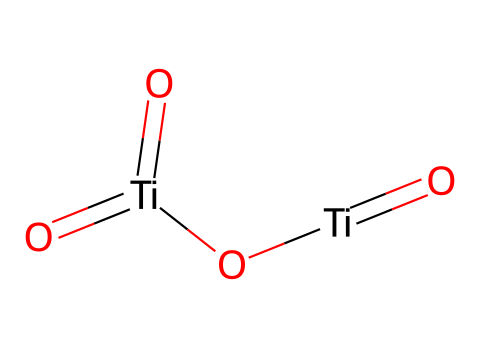What is the chemical formula for the compound represented? The SMILES representation shows two titanium (Ti) atoms, each bonded to three oxygen (O) atoms, which can be counted from the chemical structure. Therefore, the chemical formula can be deduced as Ti2O4.
Answer: Ti2O4 How many titanium atoms are present in the molecular structure? By analyzing the SMILES, we can observe that there are two instances of 'Ti', indicating the presence of two titanium atoms.
Answer: 2 What type of bonds are formed between the titanium and oxygen atoms? The notation "O=" indicates double bonds between titanium and oxygen atoms, while the lack of single-bond indicators between oxygens and titanium suggests that all are in a coordinated structure with titanium.
Answer: double bonds What type of materials does this chemical structure represent? Given the context of the question, titanium dioxide nanoparticles are known as nanomaterials used in cosmetics and sunscreens due to their UV-filtering properties.
Answer: nanomaterials Is the titanium dioxide nanoparticles structure hydrophilic or hydrophobic? Titanium dioxide is known to be hydrophilic due to its surface chemistry that interacts well with water molecules, which is crucial for its application in sunscreens.
Answer: hydrophilic What is a common use of the titanium dioxide represented in this structure? Titanium dioxide nanoparticles are primarily used as a UV filter in sunscreens to protect the skin from harmful ultraviolet rays.
Answer: UV filter 